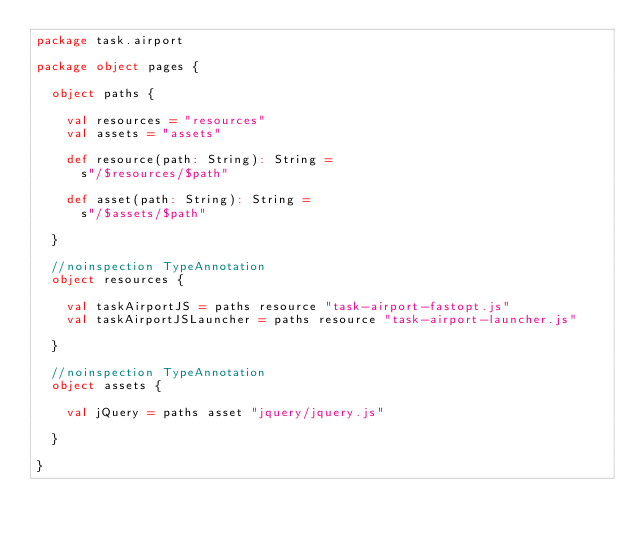<code> <loc_0><loc_0><loc_500><loc_500><_Scala_>package task.airport

package object pages {

  object paths {

    val resources = "resources"
    val assets = "assets"

    def resource(path: String): String =
      s"/$resources/$path"

    def asset(path: String): String =
      s"/$assets/$path"

  }

  //noinspection TypeAnnotation
  object resources {

    val taskAirportJS = paths resource "task-airport-fastopt.js"
    val taskAirportJSLauncher = paths resource "task-airport-launcher.js"

  }

  //noinspection TypeAnnotation
  object assets {

    val jQuery = paths asset "jquery/jquery.js"

  }

}
</code> 